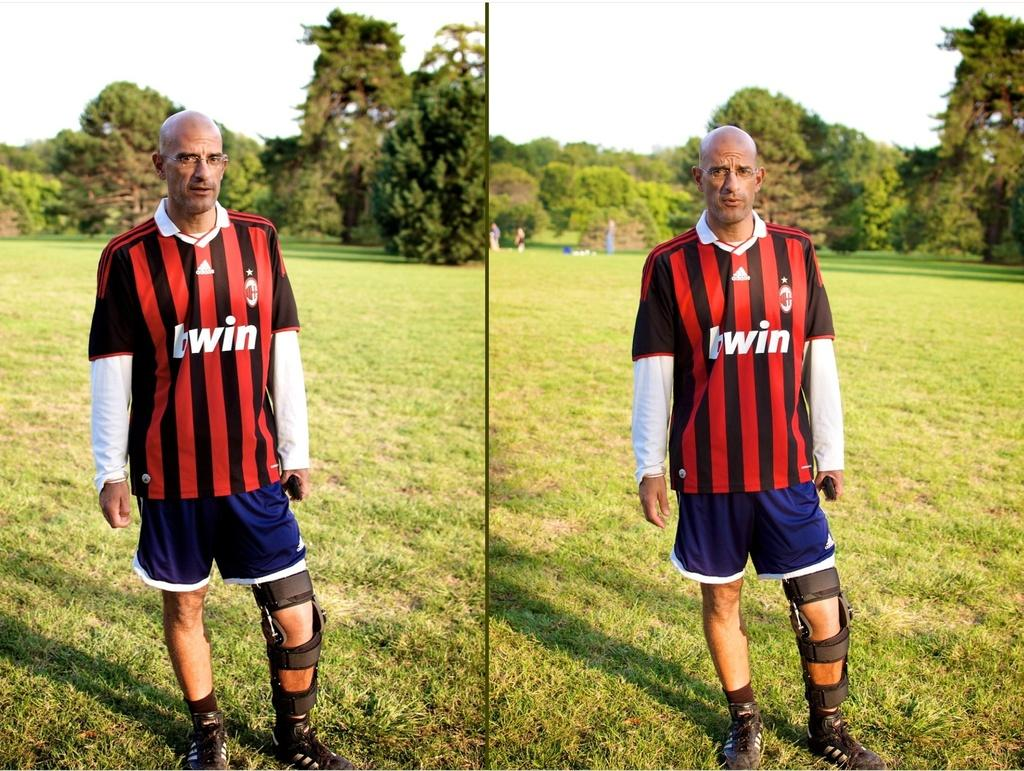<image>
Write a terse but informative summary of the picture. A man wears a striped shirt that has twin on the front. 